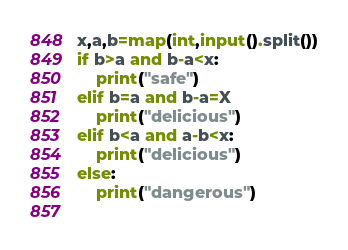Convert code to text. <code><loc_0><loc_0><loc_500><loc_500><_Python_>x,a,b=map(int,input().split())
if b>a and b-a<x:
	print("safe")
elif b=a and b-a=X
	print("delicious")
elif b<a and a-b<x:
	print("delicious")
else:
	print("dangerous")
	
</code> 